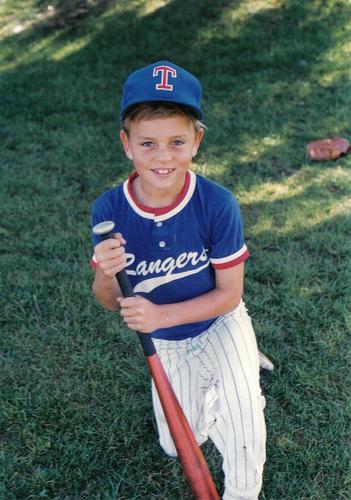What team does the child play for?
Keep it brief. Rangers. Is he holding a wooden bat?
Keep it brief. No. What team does the player play for?
Short answer required. Rangers. Is this kid practicing?
Be succinct. No. Is the boy wearing a blue shirt?
Give a very brief answer. Yes. What sex is the kid in this picture?
Quick response, please. Male. What color is the uniform?
Write a very short answer. Blue. 